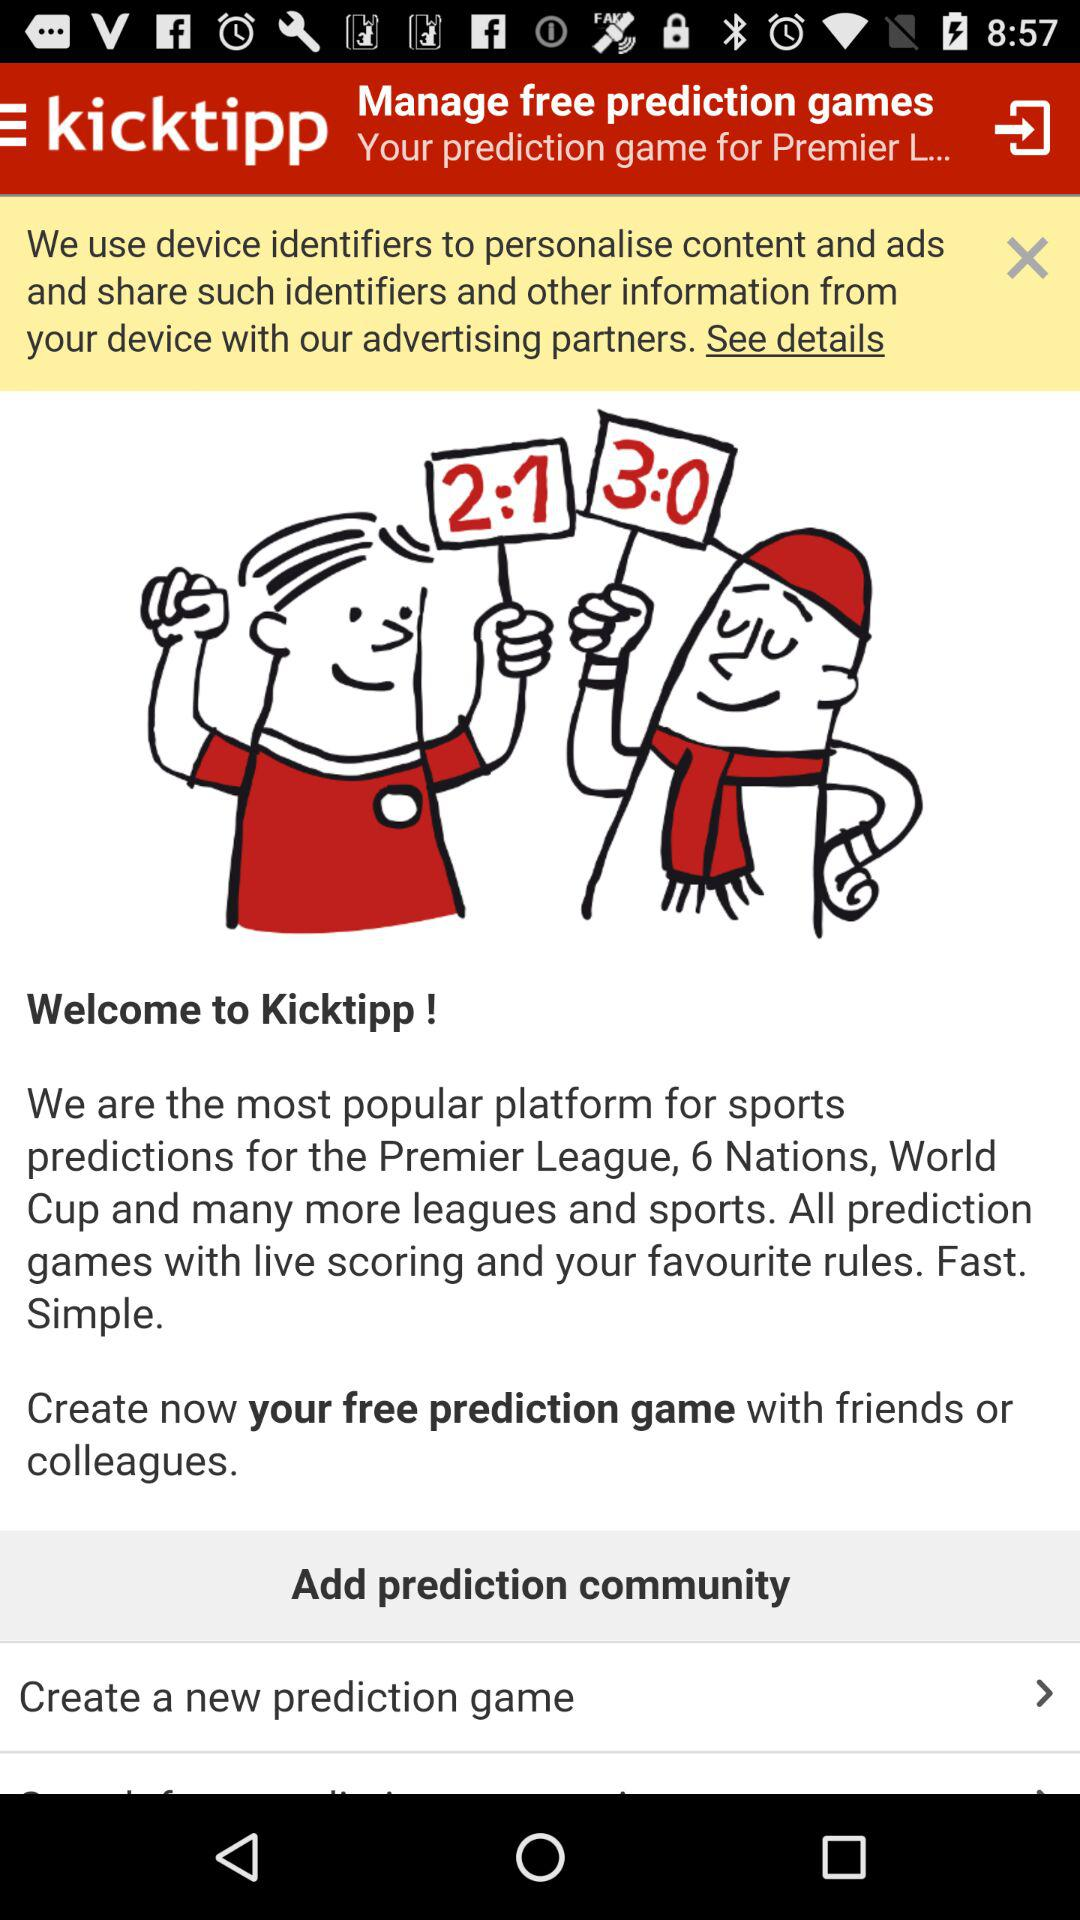What is the name of the application? The name of the application is "kicktipp". 